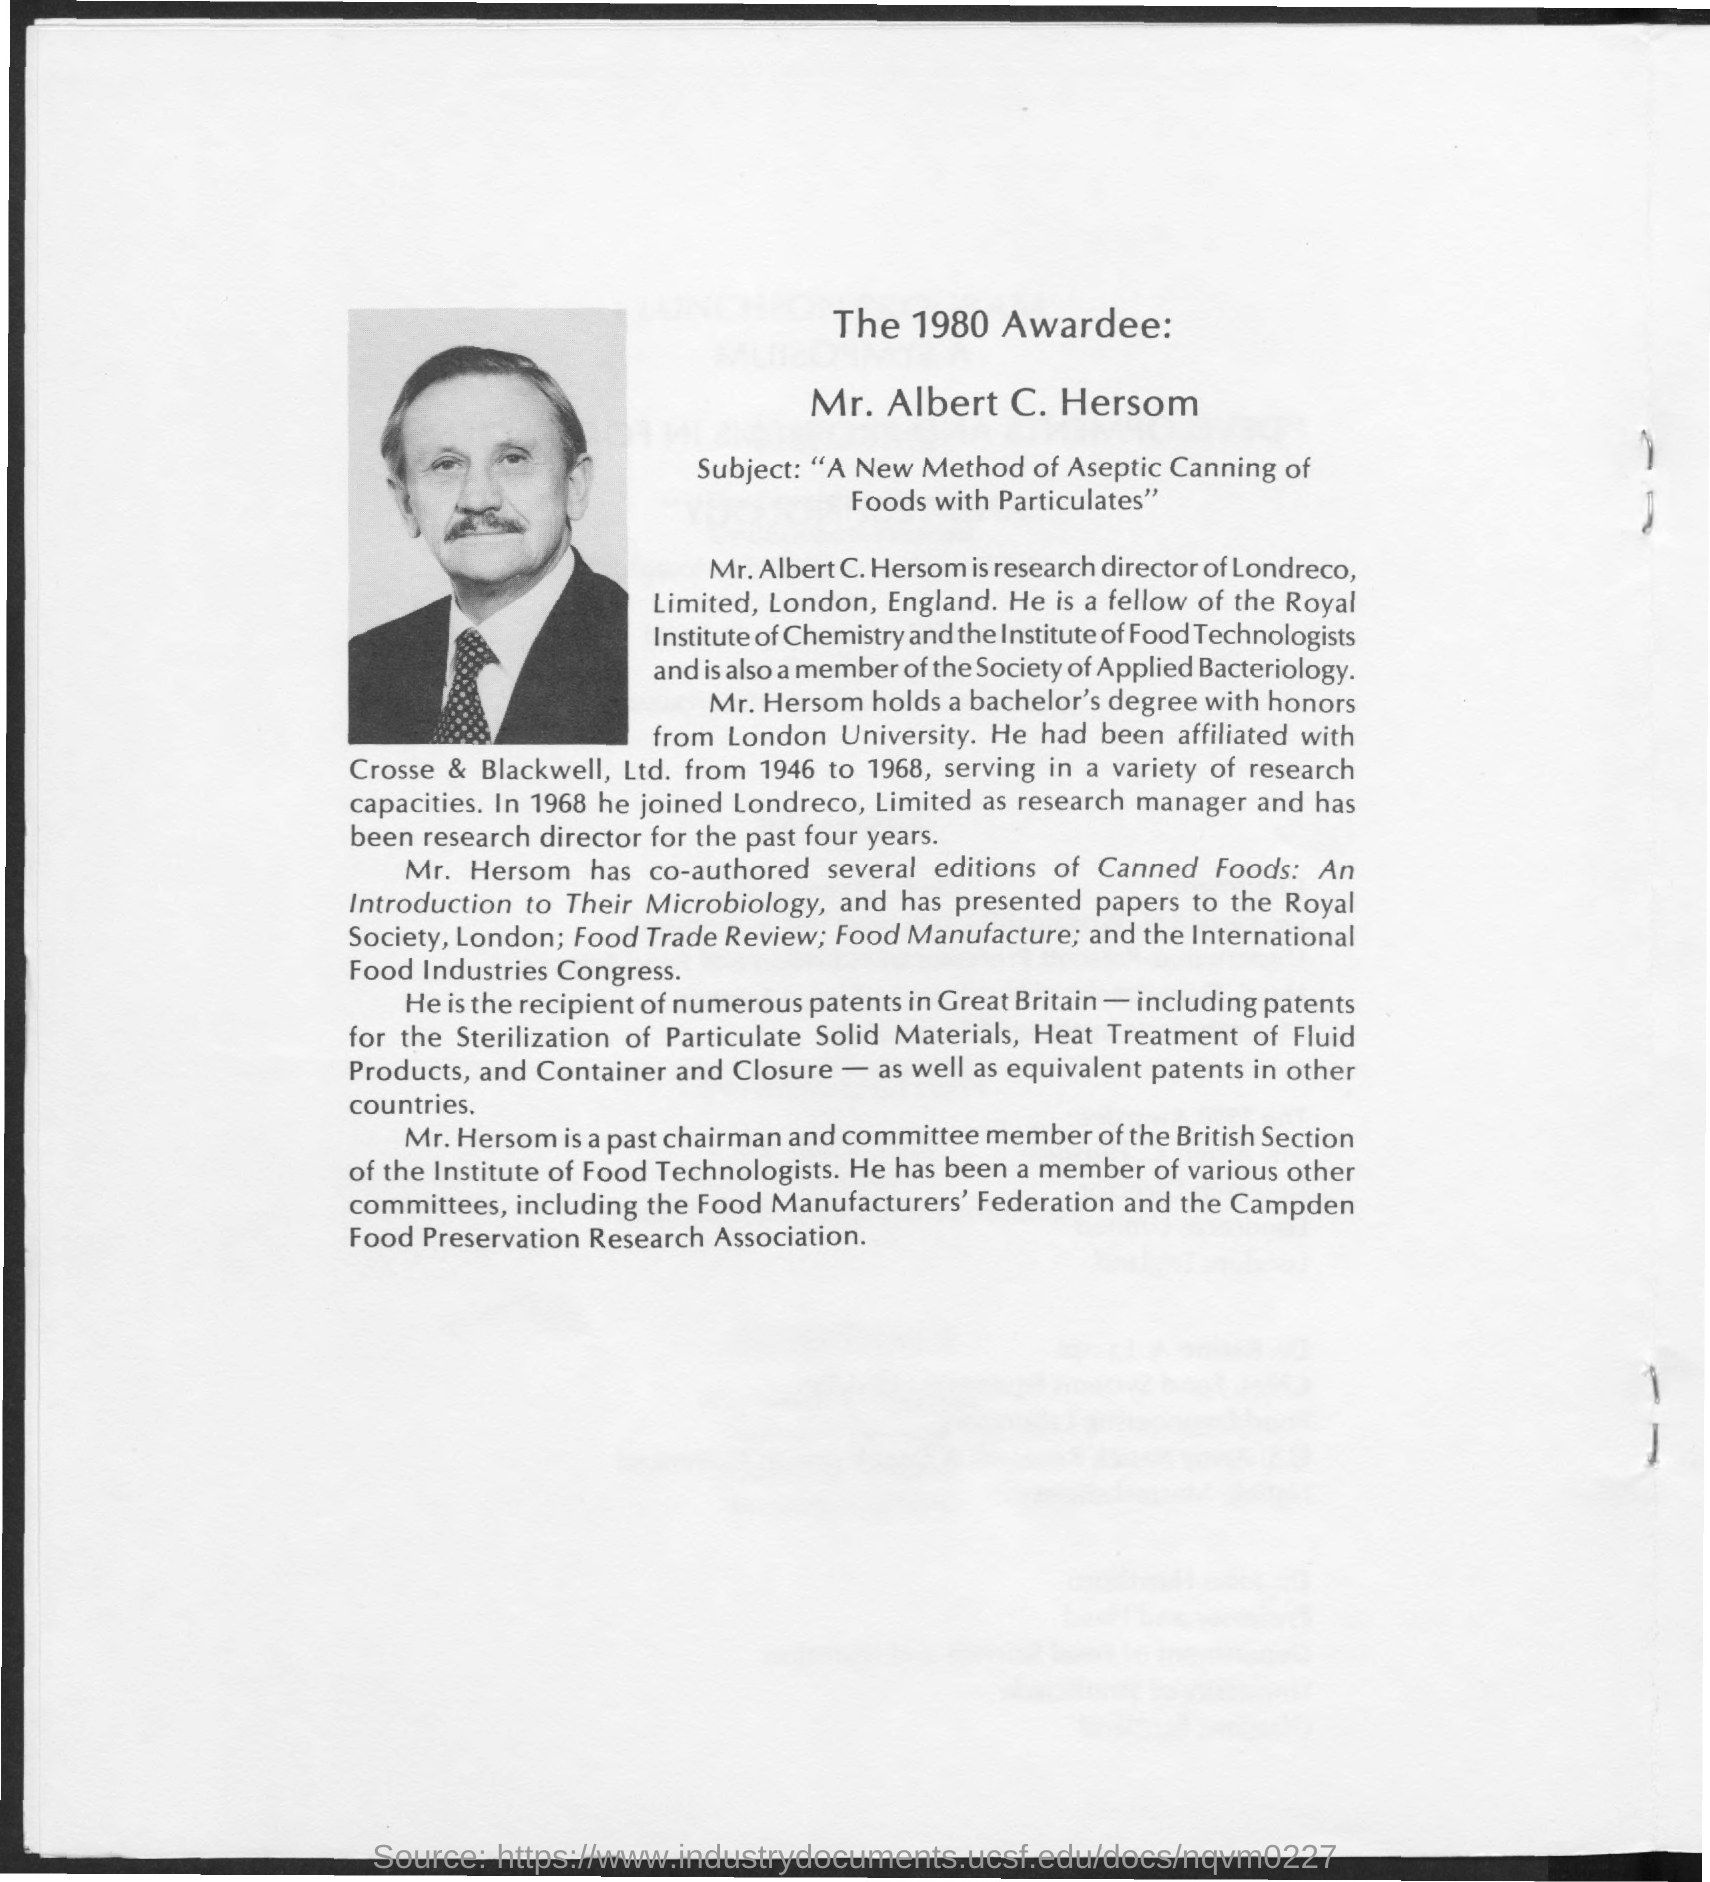Mention a couple of crucial points in this snapshot. Mr. Alber C. Hersom received the award in 1980. The award is for the outstanding achievement in the development of a novel method for aseptic canning of foods with particulate matter. 